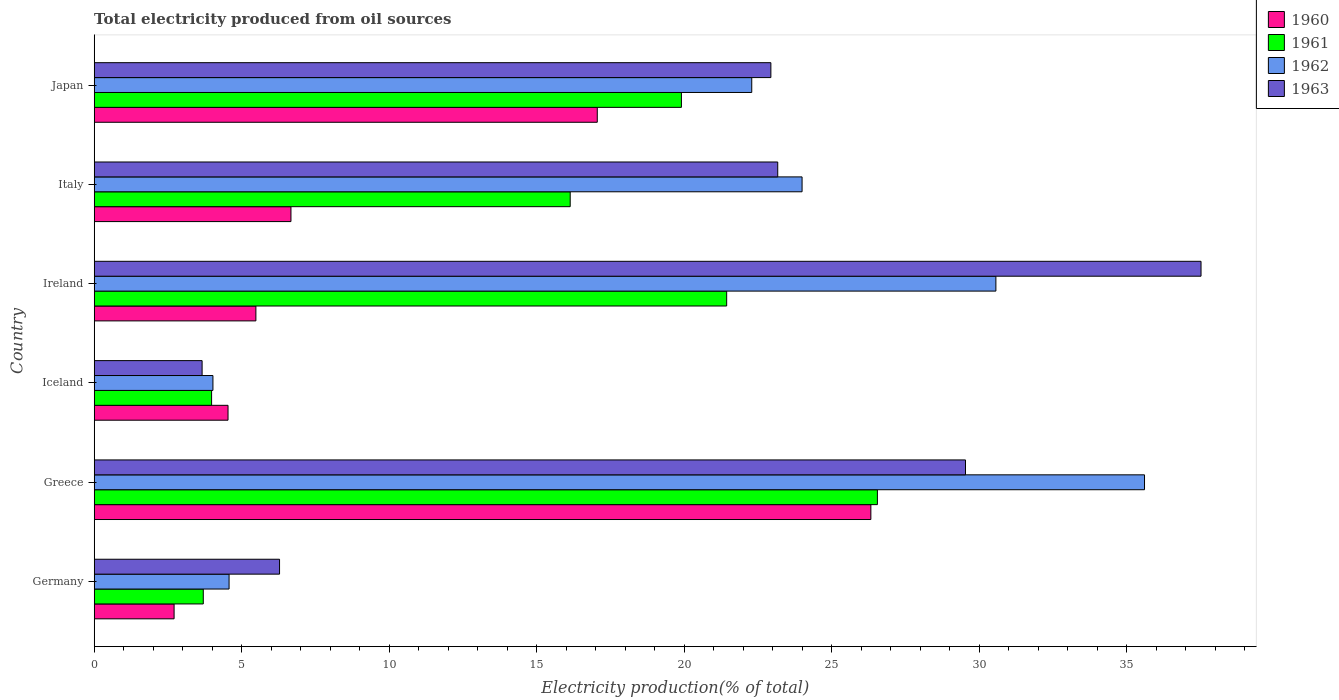How many different coloured bars are there?
Provide a succinct answer. 4. Are the number of bars on each tick of the Y-axis equal?
Your answer should be compact. Yes. What is the label of the 5th group of bars from the top?
Give a very brief answer. Greece. What is the total electricity produced in 1960 in Japan?
Keep it short and to the point. 17.06. Across all countries, what is the maximum total electricity produced in 1963?
Your response must be concise. 37.53. Across all countries, what is the minimum total electricity produced in 1961?
Your response must be concise. 3.7. What is the total total electricity produced in 1960 in the graph?
Provide a short and direct response. 62.79. What is the difference between the total electricity produced in 1962 in Germany and that in Greece?
Ensure brevity in your answer.  -31.04. What is the difference between the total electricity produced in 1962 in Japan and the total electricity produced in 1960 in Greece?
Offer a very short reply. -4.04. What is the average total electricity produced in 1962 per country?
Your answer should be very brief. 20.18. What is the difference between the total electricity produced in 1961 and total electricity produced in 1963 in Greece?
Provide a succinct answer. -2.99. What is the ratio of the total electricity produced in 1961 in Iceland to that in Ireland?
Ensure brevity in your answer.  0.19. Is the total electricity produced in 1962 in Iceland less than that in Ireland?
Offer a very short reply. Yes. What is the difference between the highest and the second highest total electricity produced in 1962?
Give a very brief answer. 5.04. What is the difference between the highest and the lowest total electricity produced in 1960?
Your answer should be compact. 23.62. In how many countries, is the total electricity produced in 1962 greater than the average total electricity produced in 1962 taken over all countries?
Give a very brief answer. 4. Is the sum of the total electricity produced in 1962 in Ireland and Italy greater than the maximum total electricity produced in 1961 across all countries?
Offer a very short reply. Yes. Is it the case that in every country, the sum of the total electricity produced in 1960 and total electricity produced in 1961 is greater than the sum of total electricity produced in 1963 and total electricity produced in 1962?
Your answer should be very brief. No. What does the 2nd bar from the top in Germany represents?
Keep it short and to the point. 1962. What does the 2nd bar from the bottom in Japan represents?
Offer a terse response. 1961. Is it the case that in every country, the sum of the total electricity produced in 1963 and total electricity produced in 1961 is greater than the total electricity produced in 1960?
Offer a terse response. Yes. How many bars are there?
Provide a short and direct response. 24. Are the values on the major ticks of X-axis written in scientific E-notation?
Give a very brief answer. No. Does the graph contain any zero values?
Your response must be concise. No. Does the graph contain grids?
Make the answer very short. No. Where does the legend appear in the graph?
Give a very brief answer. Top right. How are the legend labels stacked?
Provide a short and direct response. Vertical. What is the title of the graph?
Offer a very short reply. Total electricity produced from oil sources. What is the label or title of the X-axis?
Make the answer very short. Electricity production(% of total). What is the label or title of the Y-axis?
Your response must be concise. Country. What is the Electricity production(% of total) in 1960 in Germany?
Your response must be concise. 2.71. What is the Electricity production(% of total) in 1961 in Germany?
Your response must be concise. 3.7. What is the Electricity production(% of total) in 1962 in Germany?
Your answer should be very brief. 4.57. What is the Electricity production(% of total) of 1963 in Germany?
Your answer should be compact. 6.28. What is the Electricity production(% of total) in 1960 in Greece?
Your answer should be very brief. 26.33. What is the Electricity production(% of total) in 1961 in Greece?
Keep it short and to the point. 26.55. What is the Electricity production(% of total) in 1962 in Greece?
Your answer should be compact. 35.61. What is the Electricity production(% of total) of 1963 in Greece?
Ensure brevity in your answer.  29.54. What is the Electricity production(% of total) in 1960 in Iceland?
Ensure brevity in your answer.  4.54. What is the Electricity production(% of total) of 1961 in Iceland?
Ensure brevity in your answer.  3.98. What is the Electricity production(% of total) of 1962 in Iceland?
Your answer should be compact. 4.03. What is the Electricity production(% of total) in 1963 in Iceland?
Offer a very short reply. 3.66. What is the Electricity production(% of total) of 1960 in Ireland?
Give a very brief answer. 5.48. What is the Electricity production(% of total) in 1961 in Ireland?
Keep it short and to the point. 21.44. What is the Electricity production(% of total) of 1962 in Ireland?
Ensure brevity in your answer.  30.57. What is the Electricity production(% of total) in 1963 in Ireland?
Make the answer very short. 37.53. What is the Electricity production(% of total) of 1960 in Italy?
Your answer should be compact. 6.67. What is the Electricity production(% of total) of 1961 in Italy?
Make the answer very short. 16.14. What is the Electricity production(% of total) of 1962 in Italy?
Your answer should be very brief. 24. What is the Electricity production(% of total) of 1963 in Italy?
Your response must be concise. 23.17. What is the Electricity production(% of total) of 1960 in Japan?
Keep it short and to the point. 17.06. What is the Electricity production(% of total) in 1961 in Japan?
Give a very brief answer. 19.91. What is the Electricity production(% of total) of 1962 in Japan?
Your answer should be very brief. 22.29. What is the Electricity production(% of total) of 1963 in Japan?
Give a very brief answer. 22.94. Across all countries, what is the maximum Electricity production(% of total) of 1960?
Provide a succinct answer. 26.33. Across all countries, what is the maximum Electricity production(% of total) of 1961?
Your response must be concise. 26.55. Across all countries, what is the maximum Electricity production(% of total) in 1962?
Keep it short and to the point. 35.61. Across all countries, what is the maximum Electricity production(% of total) in 1963?
Provide a succinct answer. 37.53. Across all countries, what is the minimum Electricity production(% of total) in 1960?
Make the answer very short. 2.71. Across all countries, what is the minimum Electricity production(% of total) in 1961?
Provide a succinct answer. 3.7. Across all countries, what is the minimum Electricity production(% of total) in 1962?
Your answer should be compact. 4.03. Across all countries, what is the minimum Electricity production(% of total) in 1963?
Ensure brevity in your answer.  3.66. What is the total Electricity production(% of total) in 1960 in the graph?
Give a very brief answer. 62.79. What is the total Electricity production(% of total) in 1961 in the graph?
Your answer should be compact. 91.72. What is the total Electricity production(% of total) of 1962 in the graph?
Provide a short and direct response. 121.07. What is the total Electricity production(% of total) in 1963 in the graph?
Make the answer very short. 123.13. What is the difference between the Electricity production(% of total) of 1960 in Germany and that in Greece?
Offer a terse response. -23.62. What is the difference between the Electricity production(% of total) of 1961 in Germany and that in Greece?
Your answer should be very brief. -22.86. What is the difference between the Electricity production(% of total) in 1962 in Germany and that in Greece?
Provide a succinct answer. -31.04. What is the difference between the Electricity production(% of total) of 1963 in Germany and that in Greece?
Offer a terse response. -23.26. What is the difference between the Electricity production(% of total) of 1960 in Germany and that in Iceland?
Your answer should be very brief. -1.83. What is the difference between the Electricity production(% of total) in 1961 in Germany and that in Iceland?
Your answer should be very brief. -0.28. What is the difference between the Electricity production(% of total) in 1962 in Germany and that in Iceland?
Your answer should be very brief. 0.55. What is the difference between the Electricity production(% of total) of 1963 in Germany and that in Iceland?
Provide a short and direct response. 2.63. What is the difference between the Electricity production(% of total) in 1960 in Germany and that in Ireland?
Keep it short and to the point. -2.77. What is the difference between the Electricity production(% of total) of 1961 in Germany and that in Ireland?
Ensure brevity in your answer.  -17.75. What is the difference between the Electricity production(% of total) of 1962 in Germany and that in Ireland?
Offer a very short reply. -26. What is the difference between the Electricity production(% of total) of 1963 in Germany and that in Ireland?
Give a very brief answer. -31.24. What is the difference between the Electricity production(% of total) in 1960 in Germany and that in Italy?
Offer a terse response. -3.96. What is the difference between the Electricity production(% of total) of 1961 in Germany and that in Italy?
Offer a terse response. -12.44. What is the difference between the Electricity production(% of total) of 1962 in Germany and that in Italy?
Your response must be concise. -19.43. What is the difference between the Electricity production(% of total) in 1963 in Germany and that in Italy?
Ensure brevity in your answer.  -16.89. What is the difference between the Electricity production(% of total) of 1960 in Germany and that in Japan?
Offer a terse response. -14.35. What is the difference between the Electricity production(% of total) of 1961 in Germany and that in Japan?
Give a very brief answer. -16.21. What is the difference between the Electricity production(% of total) of 1962 in Germany and that in Japan?
Offer a terse response. -17.72. What is the difference between the Electricity production(% of total) in 1963 in Germany and that in Japan?
Offer a very short reply. -16.66. What is the difference between the Electricity production(% of total) of 1960 in Greece and that in Iceland?
Your response must be concise. 21.79. What is the difference between the Electricity production(% of total) in 1961 in Greece and that in Iceland?
Your answer should be compact. 22.57. What is the difference between the Electricity production(% of total) in 1962 in Greece and that in Iceland?
Offer a terse response. 31.58. What is the difference between the Electricity production(% of total) in 1963 in Greece and that in Iceland?
Keep it short and to the point. 25.88. What is the difference between the Electricity production(% of total) in 1960 in Greece and that in Ireland?
Provide a short and direct response. 20.85. What is the difference between the Electricity production(% of total) in 1961 in Greece and that in Ireland?
Offer a very short reply. 5.11. What is the difference between the Electricity production(% of total) in 1962 in Greece and that in Ireland?
Offer a very short reply. 5.04. What is the difference between the Electricity production(% of total) of 1963 in Greece and that in Ireland?
Keep it short and to the point. -7.99. What is the difference between the Electricity production(% of total) in 1960 in Greece and that in Italy?
Your answer should be very brief. 19.66. What is the difference between the Electricity production(% of total) of 1961 in Greece and that in Italy?
Provide a short and direct response. 10.42. What is the difference between the Electricity production(% of total) in 1962 in Greece and that in Italy?
Your answer should be compact. 11.61. What is the difference between the Electricity production(% of total) of 1963 in Greece and that in Italy?
Your response must be concise. 6.37. What is the difference between the Electricity production(% of total) in 1960 in Greece and that in Japan?
Make the answer very short. 9.28. What is the difference between the Electricity production(% of total) of 1961 in Greece and that in Japan?
Ensure brevity in your answer.  6.64. What is the difference between the Electricity production(% of total) of 1962 in Greece and that in Japan?
Keep it short and to the point. 13.32. What is the difference between the Electricity production(% of total) of 1963 in Greece and that in Japan?
Give a very brief answer. 6.6. What is the difference between the Electricity production(% of total) in 1960 in Iceland and that in Ireland?
Provide a succinct answer. -0.94. What is the difference between the Electricity production(% of total) of 1961 in Iceland and that in Ireland?
Keep it short and to the point. -17.46. What is the difference between the Electricity production(% of total) of 1962 in Iceland and that in Ireland?
Provide a succinct answer. -26.55. What is the difference between the Electricity production(% of total) in 1963 in Iceland and that in Ireland?
Offer a terse response. -33.87. What is the difference between the Electricity production(% of total) in 1960 in Iceland and that in Italy?
Provide a short and direct response. -2.13. What is the difference between the Electricity production(% of total) in 1961 in Iceland and that in Italy?
Provide a short and direct response. -12.16. What is the difference between the Electricity production(% of total) of 1962 in Iceland and that in Italy?
Your answer should be very brief. -19.97. What is the difference between the Electricity production(% of total) in 1963 in Iceland and that in Italy?
Provide a short and direct response. -19.52. What is the difference between the Electricity production(% of total) in 1960 in Iceland and that in Japan?
Your response must be concise. -12.52. What is the difference between the Electricity production(% of total) in 1961 in Iceland and that in Japan?
Your answer should be compact. -15.93. What is the difference between the Electricity production(% of total) in 1962 in Iceland and that in Japan?
Your answer should be very brief. -18.27. What is the difference between the Electricity production(% of total) of 1963 in Iceland and that in Japan?
Offer a very short reply. -19.28. What is the difference between the Electricity production(% of total) in 1960 in Ireland and that in Italy?
Keep it short and to the point. -1.19. What is the difference between the Electricity production(% of total) in 1961 in Ireland and that in Italy?
Offer a very short reply. 5.3. What is the difference between the Electricity production(% of total) in 1962 in Ireland and that in Italy?
Keep it short and to the point. 6.57. What is the difference between the Electricity production(% of total) of 1963 in Ireland and that in Italy?
Provide a succinct answer. 14.35. What is the difference between the Electricity production(% of total) in 1960 in Ireland and that in Japan?
Offer a terse response. -11.57. What is the difference between the Electricity production(% of total) of 1961 in Ireland and that in Japan?
Give a very brief answer. 1.53. What is the difference between the Electricity production(% of total) in 1962 in Ireland and that in Japan?
Give a very brief answer. 8.28. What is the difference between the Electricity production(% of total) in 1963 in Ireland and that in Japan?
Give a very brief answer. 14.58. What is the difference between the Electricity production(% of total) of 1960 in Italy and that in Japan?
Your answer should be compact. -10.39. What is the difference between the Electricity production(% of total) in 1961 in Italy and that in Japan?
Keep it short and to the point. -3.77. What is the difference between the Electricity production(% of total) of 1962 in Italy and that in Japan?
Keep it short and to the point. 1.71. What is the difference between the Electricity production(% of total) in 1963 in Italy and that in Japan?
Offer a terse response. 0.23. What is the difference between the Electricity production(% of total) in 1960 in Germany and the Electricity production(% of total) in 1961 in Greece?
Make the answer very short. -23.85. What is the difference between the Electricity production(% of total) in 1960 in Germany and the Electricity production(% of total) in 1962 in Greece?
Offer a terse response. -32.9. What is the difference between the Electricity production(% of total) of 1960 in Germany and the Electricity production(% of total) of 1963 in Greece?
Your answer should be compact. -26.83. What is the difference between the Electricity production(% of total) of 1961 in Germany and the Electricity production(% of total) of 1962 in Greece?
Your answer should be very brief. -31.91. What is the difference between the Electricity production(% of total) of 1961 in Germany and the Electricity production(% of total) of 1963 in Greece?
Your response must be concise. -25.84. What is the difference between the Electricity production(% of total) in 1962 in Germany and the Electricity production(% of total) in 1963 in Greece?
Make the answer very short. -24.97. What is the difference between the Electricity production(% of total) in 1960 in Germany and the Electricity production(% of total) in 1961 in Iceland?
Ensure brevity in your answer.  -1.27. What is the difference between the Electricity production(% of total) of 1960 in Germany and the Electricity production(% of total) of 1962 in Iceland?
Make the answer very short. -1.32. What is the difference between the Electricity production(% of total) of 1960 in Germany and the Electricity production(% of total) of 1963 in Iceland?
Give a very brief answer. -0.95. What is the difference between the Electricity production(% of total) in 1961 in Germany and the Electricity production(% of total) in 1962 in Iceland?
Ensure brevity in your answer.  -0.33. What is the difference between the Electricity production(% of total) of 1961 in Germany and the Electricity production(% of total) of 1963 in Iceland?
Provide a succinct answer. 0.04. What is the difference between the Electricity production(% of total) in 1962 in Germany and the Electricity production(% of total) in 1963 in Iceland?
Provide a succinct answer. 0.91. What is the difference between the Electricity production(% of total) in 1960 in Germany and the Electricity production(% of total) in 1961 in Ireland?
Your answer should be very brief. -18.73. What is the difference between the Electricity production(% of total) of 1960 in Germany and the Electricity production(% of total) of 1962 in Ireland?
Your answer should be compact. -27.86. What is the difference between the Electricity production(% of total) in 1960 in Germany and the Electricity production(% of total) in 1963 in Ireland?
Your response must be concise. -34.82. What is the difference between the Electricity production(% of total) in 1961 in Germany and the Electricity production(% of total) in 1962 in Ireland?
Give a very brief answer. -26.87. What is the difference between the Electricity production(% of total) of 1961 in Germany and the Electricity production(% of total) of 1963 in Ireland?
Provide a succinct answer. -33.83. What is the difference between the Electricity production(% of total) of 1962 in Germany and the Electricity production(% of total) of 1963 in Ireland?
Offer a very short reply. -32.95. What is the difference between the Electricity production(% of total) of 1960 in Germany and the Electricity production(% of total) of 1961 in Italy?
Your answer should be compact. -13.43. What is the difference between the Electricity production(% of total) in 1960 in Germany and the Electricity production(% of total) in 1962 in Italy?
Ensure brevity in your answer.  -21.29. What is the difference between the Electricity production(% of total) of 1960 in Germany and the Electricity production(% of total) of 1963 in Italy?
Give a very brief answer. -20.47. What is the difference between the Electricity production(% of total) of 1961 in Germany and the Electricity production(% of total) of 1962 in Italy?
Your response must be concise. -20.3. What is the difference between the Electricity production(% of total) of 1961 in Germany and the Electricity production(% of total) of 1963 in Italy?
Keep it short and to the point. -19.48. What is the difference between the Electricity production(% of total) in 1962 in Germany and the Electricity production(% of total) in 1963 in Italy?
Offer a terse response. -18.6. What is the difference between the Electricity production(% of total) in 1960 in Germany and the Electricity production(% of total) in 1961 in Japan?
Make the answer very short. -17.2. What is the difference between the Electricity production(% of total) of 1960 in Germany and the Electricity production(% of total) of 1962 in Japan?
Provide a short and direct response. -19.58. What is the difference between the Electricity production(% of total) in 1960 in Germany and the Electricity production(% of total) in 1963 in Japan?
Your response must be concise. -20.23. What is the difference between the Electricity production(% of total) of 1961 in Germany and the Electricity production(% of total) of 1962 in Japan?
Keep it short and to the point. -18.6. What is the difference between the Electricity production(% of total) in 1961 in Germany and the Electricity production(% of total) in 1963 in Japan?
Your response must be concise. -19.24. What is the difference between the Electricity production(% of total) in 1962 in Germany and the Electricity production(% of total) in 1963 in Japan?
Provide a short and direct response. -18.37. What is the difference between the Electricity production(% of total) of 1960 in Greece and the Electricity production(% of total) of 1961 in Iceland?
Ensure brevity in your answer.  22.35. What is the difference between the Electricity production(% of total) in 1960 in Greece and the Electricity production(% of total) in 1962 in Iceland?
Provide a short and direct response. 22.31. What is the difference between the Electricity production(% of total) in 1960 in Greece and the Electricity production(% of total) in 1963 in Iceland?
Provide a succinct answer. 22.67. What is the difference between the Electricity production(% of total) in 1961 in Greece and the Electricity production(% of total) in 1962 in Iceland?
Your response must be concise. 22.53. What is the difference between the Electricity production(% of total) in 1961 in Greece and the Electricity production(% of total) in 1963 in Iceland?
Give a very brief answer. 22.9. What is the difference between the Electricity production(% of total) in 1962 in Greece and the Electricity production(% of total) in 1963 in Iceland?
Provide a succinct answer. 31.95. What is the difference between the Electricity production(% of total) of 1960 in Greece and the Electricity production(% of total) of 1961 in Ireland?
Your answer should be compact. 4.89. What is the difference between the Electricity production(% of total) in 1960 in Greece and the Electricity production(% of total) in 1962 in Ireland?
Make the answer very short. -4.24. What is the difference between the Electricity production(% of total) of 1960 in Greece and the Electricity production(% of total) of 1963 in Ireland?
Your answer should be compact. -11.19. What is the difference between the Electricity production(% of total) in 1961 in Greece and the Electricity production(% of total) in 1962 in Ireland?
Provide a succinct answer. -4.02. What is the difference between the Electricity production(% of total) of 1961 in Greece and the Electricity production(% of total) of 1963 in Ireland?
Make the answer very short. -10.97. What is the difference between the Electricity production(% of total) in 1962 in Greece and the Electricity production(% of total) in 1963 in Ireland?
Ensure brevity in your answer.  -1.92. What is the difference between the Electricity production(% of total) in 1960 in Greece and the Electricity production(% of total) in 1961 in Italy?
Make the answer very short. 10.19. What is the difference between the Electricity production(% of total) in 1960 in Greece and the Electricity production(% of total) in 1962 in Italy?
Your answer should be compact. 2.33. What is the difference between the Electricity production(% of total) in 1960 in Greece and the Electricity production(% of total) in 1963 in Italy?
Provide a succinct answer. 3.16. What is the difference between the Electricity production(% of total) in 1961 in Greece and the Electricity production(% of total) in 1962 in Italy?
Give a very brief answer. 2.55. What is the difference between the Electricity production(% of total) of 1961 in Greece and the Electricity production(% of total) of 1963 in Italy?
Your answer should be very brief. 3.38. What is the difference between the Electricity production(% of total) of 1962 in Greece and the Electricity production(% of total) of 1963 in Italy?
Your response must be concise. 12.44. What is the difference between the Electricity production(% of total) in 1960 in Greece and the Electricity production(% of total) in 1961 in Japan?
Offer a terse response. 6.42. What is the difference between the Electricity production(% of total) of 1960 in Greece and the Electricity production(% of total) of 1962 in Japan?
Provide a succinct answer. 4.04. What is the difference between the Electricity production(% of total) in 1960 in Greece and the Electricity production(% of total) in 1963 in Japan?
Provide a short and direct response. 3.39. What is the difference between the Electricity production(% of total) of 1961 in Greece and the Electricity production(% of total) of 1962 in Japan?
Make the answer very short. 4.26. What is the difference between the Electricity production(% of total) in 1961 in Greece and the Electricity production(% of total) in 1963 in Japan?
Your response must be concise. 3.61. What is the difference between the Electricity production(% of total) in 1962 in Greece and the Electricity production(% of total) in 1963 in Japan?
Ensure brevity in your answer.  12.67. What is the difference between the Electricity production(% of total) of 1960 in Iceland and the Electricity production(% of total) of 1961 in Ireland?
Your answer should be very brief. -16.91. What is the difference between the Electricity production(% of total) in 1960 in Iceland and the Electricity production(% of total) in 1962 in Ireland?
Your answer should be compact. -26.03. What is the difference between the Electricity production(% of total) of 1960 in Iceland and the Electricity production(% of total) of 1963 in Ireland?
Give a very brief answer. -32.99. What is the difference between the Electricity production(% of total) in 1961 in Iceland and the Electricity production(% of total) in 1962 in Ireland?
Make the answer very short. -26.59. What is the difference between the Electricity production(% of total) of 1961 in Iceland and the Electricity production(% of total) of 1963 in Ireland?
Ensure brevity in your answer.  -33.55. What is the difference between the Electricity production(% of total) of 1962 in Iceland and the Electricity production(% of total) of 1963 in Ireland?
Your response must be concise. -33.5. What is the difference between the Electricity production(% of total) of 1960 in Iceland and the Electricity production(% of total) of 1961 in Italy?
Keep it short and to the point. -11.6. What is the difference between the Electricity production(% of total) in 1960 in Iceland and the Electricity production(% of total) in 1962 in Italy?
Your answer should be very brief. -19.46. What is the difference between the Electricity production(% of total) of 1960 in Iceland and the Electricity production(% of total) of 1963 in Italy?
Give a very brief answer. -18.64. What is the difference between the Electricity production(% of total) in 1961 in Iceland and the Electricity production(% of total) in 1962 in Italy?
Your answer should be very brief. -20.02. What is the difference between the Electricity production(% of total) of 1961 in Iceland and the Electricity production(% of total) of 1963 in Italy?
Offer a very short reply. -19.19. What is the difference between the Electricity production(% of total) in 1962 in Iceland and the Electricity production(% of total) in 1963 in Italy?
Give a very brief answer. -19.15. What is the difference between the Electricity production(% of total) of 1960 in Iceland and the Electricity production(% of total) of 1961 in Japan?
Give a very brief answer. -15.37. What is the difference between the Electricity production(% of total) in 1960 in Iceland and the Electricity production(% of total) in 1962 in Japan?
Provide a succinct answer. -17.76. What is the difference between the Electricity production(% of total) in 1960 in Iceland and the Electricity production(% of total) in 1963 in Japan?
Provide a succinct answer. -18.4. What is the difference between the Electricity production(% of total) of 1961 in Iceland and the Electricity production(% of total) of 1962 in Japan?
Make the answer very short. -18.31. What is the difference between the Electricity production(% of total) in 1961 in Iceland and the Electricity production(% of total) in 1963 in Japan?
Ensure brevity in your answer.  -18.96. What is the difference between the Electricity production(% of total) of 1962 in Iceland and the Electricity production(% of total) of 1963 in Japan?
Your answer should be compact. -18.92. What is the difference between the Electricity production(% of total) in 1960 in Ireland and the Electricity production(% of total) in 1961 in Italy?
Offer a very short reply. -10.66. What is the difference between the Electricity production(% of total) of 1960 in Ireland and the Electricity production(% of total) of 1962 in Italy?
Make the answer very short. -18.52. What is the difference between the Electricity production(% of total) in 1960 in Ireland and the Electricity production(% of total) in 1963 in Italy?
Make the answer very short. -17.69. What is the difference between the Electricity production(% of total) of 1961 in Ireland and the Electricity production(% of total) of 1962 in Italy?
Provide a short and direct response. -2.56. What is the difference between the Electricity production(% of total) in 1961 in Ireland and the Electricity production(% of total) in 1963 in Italy?
Your answer should be very brief. -1.73. What is the difference between the Electricity production(% of total) in 1962 in Ireland and the Electricity production(% of total) in 1963 in Italy?
Give a very brief answer. 7.4. What is the difference between the Electricity production(% of total) of 1960 in Ireland and the Electricity production(% of total) of 1961 in Japan?
Keep it short and to the point. -14.43. What is the difference between the Electricity production(% of total) in 1960 in Ireland and the Electricity production(% of total) in 1962 in Japan?
Your response must be concise. -16.81. What is the difference between the Electricity production(% of total) of 1960 in Ireland and the Electricity production(% of total) of 1963 in Japan?
Your answer should be very brief. -17.46. What is the difference between the Electricity production(% of total) in 1961 in Ireland and the Electricity production(% of total) in 1962 in Japan?
Your answer should be compact. -0.85. What is the difference between the Electricity production(% of total) in 1961 in Ireland and the Electricity production(% of total) in 1963 in Japan?
Your answer should be very brief. -1.5. What is the difference between the Electricity production(% of total) of 1962 in Ireland and the Electricity production(% of total) of 1963 in Japan?
Provide a succinct answer. 7.63. What is the difference between the Electricity production(% of total) of 1960 in Italy and the Electricity production(% of total) of 1961 in Japan?
Provide a succinct answer. -13.24. What is the difference between the Electricity production(% of total) of 1960 in Italy and the Electricity production(% of total) of 1962 in Japan?
Ensure brevity in your answer.  -15.62. What is the difference between the Electricity production(% of total) in 1960 in Italy and the Electricity production(% of total) in 1963 in Japan?
Your response must be concise. -16.27. What is the difference between the Electricity production(% of total) of 1961 in Italy and the Electricity production(% of total) of 1962 in Japan?
Offer a very short reply. -6.15. What is the difference between the Electricity production(% of total) in 1961 in Italy and the Electricity production(% of total) in 1963 in Japan?
Your answer should be compact. -6.8. What is the difference between the Electricity production(% of total) of 1962 in Italy and the Electricity production(% of total) of 1963 in Japan?
Your answer should be very brief. 1.06. What is the average Electricity production(% of total) of 1960 per country?
Give a very brief answer. 10.46. What is the average Electricity production(% of total) in 1961 per country?
Your answer should be compact. 15.29. What is the average Electricity production(% of total) of 1962 per country?
Ensure brevity in your answer.  20.18. What is the average Electricity production(% of total) in 1963 per country?
Your answer should be very brief. 20.52. What is the difference between the Electricity production(% of total) of 1960 and Electricity production(% of total) of 1961 in Germany?
Give a very brief answer. -0.99. What is the difference between the Electricity production(% of total) in 1960 and Electricity production(% of total) in 1962 in Germany?
Provide a short and direct response. -1.86. What is the difference between the Electricity production(% of total) of 1960 and Electricity production(% of total) of 1963 in Germany?
Ensure brevity in your answer.  -3.58. What is the difference between the Electricity production(% of total) in 1961 and Electricity production(% of total) in 1962 in Germany?
Your answer should be compact. -0.87. What is the difference between the Electricity production(% of total) of 1961 and Electricity production(% of total) of 1963 in Germany?
Your response must be concise. -2.59. What is the difference between the Electricity production(% of total) of 1962 and Electricity production(% of total) of 1963 in Germany?
Make the answer very short. -1.71. What is the difference between the Electricity production(% of total) of 1960 and Electricity production(% of total) of 1961 in Greece?
Keep it short and to the point. -0.22. What is the difference between the Electricity production(% of total) in 1960 and Electricity production(% of total) in 1962 in Greece?
Give a very brief answer. -9.28. What is the difference between the Electricity production(% of total) in 1960 and Electricity production(% of total) in 1963 in Greece?
Offer a very short reply. -3.21. What is the difference between the Electricity production(% of total) in 1961 and Electricity production(% of total) in 1962 in Greece?
Your answer should be compact. -9.06. What is the difference between the Electricity production(% of total) in 1961 and Electricity production(% of total) in 1963 in Greece?
Your answer should be very brief. -2.99. What is the difference between the Electricity production(% of total) in 1962 and Electricity production(% of total) in 1963 in Greece?
Make the answer very short. 6.07. What is the difference between the Electricity production(% of total) of 1960 and Electricity production(% of total) of 1961 in Iceland?
Provide a succinct answer. 0.56. What is the difference between the Electricity production(% of total) in 1960 and Electricity production(% of total) in 1962 in Iceland?
Give a very brief answer. 0.51. What is the difference between the Electricity production(% of total) in 1960 and Electricity production(% of total) in 1963 in Iceland?
Offer a terse response. 0.88. What is the difference between the Electricity production(% of total) of 1961 and Electricity production(% of total) of 1962 in Iceland?
Offer a very short reply. -0.05. What is the difference between the Electricity production(% of total) in 1961 and Electricity production(% of total) in 1963 in Iceland?
Your response must be concise. 0.32. What is the difference between the Electricity production(% of total) in 1962 and Electricity production(% of total) in 1963 in Iceland?
Make the answer very short. 0.37. What is the difference between the Electricity production(% of total) in 1960 and Electricity production(% of total) in 1961 in Ireland?
Keep it short and to the point. -15.96. What is the difference between the Electricity production(% of total) in 1960 and Electricity production(% of total) in 1962 in Ireland?
Your answer should be very brief. -25.09. What is the difference between the Electricity production(% of total) of 1960 and Electricity production(% of total) of 1963 in Ireland?
Your response must be concise. -32.04. What is the difference between the Electricity production(% of total) in 1961 and Electricity production(% of total) in 1962 in Ireland?
Offer a terse response. -9.13. What is the difference between the Electricity production(% of total) in 1961 and Electricity production(% of total) in 1963 in Ireland?
Your answer should be very brief. -16.08. What is the difference between the Electricity production(% of total) in 1962 and Electricity production(% of total) in 1963 in Ireland?
Provide a succinct answer. -6.95. What is the difference between the Electricity production(% of total) in 1960 and Electricity production(% of total) in 1961 in Italy?
Give a very brief answer. -9.47. What is the difference between the Electricity production(% of total) in 1960 and Electricity production(% of total) in 1962 in Italy?
Offer a very short reply. -17.33. What is the difference between the Electricity production(% of total) in 1960 and Electricity production(% of total) in 1963 in Italy?
Make the answer very short. -16.5. What is the difference between the Electricity production(% of total) in 1961 and Electricity production(% of total) in 1962 in Italy?
Your answer should be very brief. -7.86. What is the difference between the Electricity production(% of total) of 1961 and Electricity production(% of total) of 1963 in Italy?
Your answer should be very brief. -7.04. What is the difference between the Electricity production(% of total) in 1962 and Electricity production(% of total) in 1963 in Italy?
Give a very brief answer. 0.83. What is the difference between the Electricity production(% of total) of 1960 and Electricity production(% of total) of 1961 in Japan?
Your answer should be compact. -2.85. What is the difference between the Electricity production(% of total) in 1960 and Electricity production(% of total) in 1962 in Japan?
Provide a short and direct response. -5.24. What is the difference between the Electricity production(% of total) of 1960 and Electricity production(% of total) of 1963 in Japan?
Provide a short and direct response. -5.89. What is the difference between the Electricity production(% of total) of 1961 and Electricity production(% of total) of 1962 in Japan?
Offer a very short reply. -2.38. What is the difference between the Electricity production(% of total) in 1961 and Electricity production(% of total) in 1963 in Japan?
Make the answer very short. -3.03. What is the difference between the Electricity production(% of total) in 1962 and Electricity production(% of total) in 1963 in Japan?
Keep it short and to the point. -0.65. What is the ratio of the Electricity production(% of total) of 1960 in Germany to that in Greece?
Provide a succinct answer. 0.1. What is the ratio of the Electricity production(% of total) in 1961 in Germany to that in Greece?
Provide a short and direct response. 0.14. What is the ratio of the Electricity production(% of total) in 1962 in Germany to that in Greece?
Offer a very short reply. 0.13. What is the ratio of the Electricity production(% of total) in 1963 in Germany to that in Greece?
Ensure brevity in your answer.  0.21. What is the ratio of the Electricity production(% of total) of 1960 in Germany to that in Iceland?
Offer a very short reply. 0.6. What is the ratio of the Electricity production(% of total) in 1961 in Germany to that in Iceland?
Ensure brevity in your answer.  0.93. What is the ratio of the Electricity production(% of total) in 1962 in Germany to that in Iceland?
Keep it short and to the point. 1.14. What is the ratio of the Electricity production(% of total) in 1963 in Germany to that in Iceland?
Provide a short and direct response. 1.72. What is the ratio of the Electricity production(% of total) of 1960 in Germany to that in Ireland?
Keep it short and to the point. 0.49. What is the ratio of the Electricity production(% of total) of 1961 in Germany to that in Ireland?
Ensure brevity in your answer.  0.17. What is the ratio of the Electricity production(% of total) of 1962 in Germany to that in Ireland?
Offer a terse response. 0.15. What is the ratio of the Electricity production(% of total) of 1963 in Germany to that in Ireland?
Ensure brevity in your answer.  0.17. What is the ratio of the Electricity production(% of total) of 1960 in Germany to that in Italy?
Offer a very short reply. 0.41. What is the ratio of the Electricity production(% of total) of 1961 in Germany to that in Italy?
Ensure brevity in your answer.  0.23. What is the ratio of the Electricity production(% of total) in 1962 in Germany to that in Italy?
Keep it short and to the point. 0.19. What is the ratio of the Electricity production(% of total) in 1963 in Germany to that in Italy?
Make the answer very short. 0.27. What is the ratio of the Electricity production(% of total) in 1960 in Germany to that in Japan?
Give a very brief answer. 0.16. What is the ratio of the Electricity production(% of total) of 1961 in Germany to that in Japan?
Your response must be concise. 0.19. What is the ratio of the Electricity production(% of total) in 1962 in Germany to that in Japan?
Keep it short and to the point. 0.21. What is the ratio of the Electricity production(% of total) in 1963 in Germany to that in Japan?
Make the answer very short. 0.27. What is the ratio of the Electricity production(% of total) in 1960 in Greece to that in Iceland?
Provide a short and direct response. 5.8. What is the ratio of the Electricity production(% of total) in 1961 in Greece to that in Iceland?
Provide a short and direct response. 6.67. What is the ratio of the Electricity production(% of total) of 1962 in Greece to that in Iceland?
Keep it short and to the point. 8.85. What is the ratio of the Electricity production(% of total) of 1963 in Greece to that in Iceland?
Your response must be concise. 8.07. What is the ratio of the Electricity production(% of total) in 1960 in Greece to that in Ireland?
Offer a terse response. 4.8. What is the ratio of the Electricity production(% of total) in 1961 in Greece to that in Ireland?
Offer a terse response. 1.24. What is the ratio of the Electricity production(% of total) of 1962 in Greece to that in Ireland?
Make the answer very short. 1.16. What is the ratio of the Electricity production(% of total) of 1963 in Greece to that in Ireland?
Your response must be concise. 0.79. What is the ratio of the Electricity production(% of total) in 1960 in Greece to that in Italy?
Ensure brevity in your answer.  3.95. What is the ratio of the Electricity production(% of total) of 1961 in Greece to that in Italy?
Make the answer very short. 1.65. What is the ratio of the Electricity production(% of total) in 1962 in Greece to that in Italy?
Offer a terse response. 1.48. What is the ratio of the Electricity production(% of total) of 1963 in Greece to that in Italy?
Make the answer very short. 1.27. What is the ratio of the Electricity production(% of total) of 1960 in Greece to that in Japan?
Offer a very short reply. 1.54. What is the ratio of the Electricity production(% of total) in 1961 in Greece to that in Japan?
Offer a terse response. 1.33. What is the ratio of the Electricity production(% of total) of 1962 in Greece to that in Japan?
Make the answer very short. 1.6. What is the ratio of the Electricity production(% of total) in 1963 in Greece to that in Japan?
Your response must be concise. 1.29. What is the ratio of the Electricity production(% of total) in 1960 in Iceland to that in Ireland?
Make the answer very short. 0.83. What is the ratio of the Electricity production(% of total) of 1961 in Iceland to that in Ireland?
Your response must be concise. 0.19. What is the ratio of the Electricity production(% of total) of 1962 in Iceland to that in Ireland?
Provide a short and direct response. 0.13. What is the ratio of the Electricity production(% of total) in 1963 in Iceland to that in Ireland?
Your answer should be very brief. 0.1. What is the ratio of the Electricity production(% of total) of 1960 in Iceland to that in Italy?
Offer a terse response. 0.68. What is the ratio of the Electricity production(% of total) of 1961 in Iceland to that in Italy?
Offer a terse response. 0.25. What is the ratio of the Electricity production(% of total) in 1962 in Iceland to that in Italy?
Give a very brief answer. 0.17. What is the ratio of the Electricity production(% of total) in 1963 in Iceland to that in Italy?
Make the answer very short. 0.16. What is the ratio of the Electricity production(% of total) in 1960 in Iceland to that in Japan?
Offer a very short reply. 0.27. What is the ratio of the Electricity production(% of total) in 1961 in Iceland to that in Japan?
Your response must be concise. 0.2. What is the ratio of the Electricity production(% of total) of 1962 in Iceland to that in Japan?
Provide a short and direct response. 0.18. What is the ratio of the Electricity production(% of total) in 1963 in Iceland to that in Japan?
Provide a short and direct response. 0.16. What is the ratio of the Electricity production(% of total) of 1960 in Ireland to that in Italy?
Your answer should be very brief. 0.82. What is the ratio of the Electricity production(% of total) in 1961 in Ireland to that in Italy?
Your answer should be compact. 1.33. What is the ratio of the Electricity production(% of total) in 1962 in Ireland to that in Italy?
Offer a very short reply. 1.27. What is the ratio of the Electricity production(% of total) of 1963 in Ireland to that in Italy?
Your answer should be compact. 1.62. What is the ratio of the Electricity production(% of total) of 1960 in Ireland to that in Japan?
Offer a very short reply. 0.32. What is the ratio of the Electricity production(% of total) of 1961 in Ireland to that in Japan?
Make the answer very short. 1.08. What is the ratio of the Electricity production(% of total) in 1962 in Ireland to that in Japan?
Ensure brevity in your answer.  1.37. What is the ratio of the Electricity production(% of total) of 1963 in Ireland to that in Japan?
Offer a terse response. 1.64. What is the ratio of the Electricity production(% of total) of 1960 in Italy to that in Japan?
Make the answer very short. 0.39. What is the ratio of the Electricity production(% of total) of 1961 in Italy to that in Japan?
Provide a succinct answer. 0.81. What is the ratio of the Electricity production(% of total) of 1962 in Italy to that in Japan?
Your answer should be compact. 1.08. What is the difference between the highest and the second highest Electricity production(% of total) of 1960?
Ensure brevity in your answer.  9.28. What is the difference between the highest and the second highest Electricity production(% of total) in 1961?
Offer a terse response. 5.11. What is the difference between the highest and the second highest Electricity production(% of total) of 1962?
Your response must be concise. 5.04. What is the difference between the highest and the second highest Electricity production(% of total) of 1963?
Keep it short and to the point. 7.99. What is the difference between the highest and the lowest Electricity production(% of total) in 1960?
Ensure brevity in your answer.  23.62. What is the difference between the highest and the lowest Electricity production(% of total) of 1961?
Your answer should be very brief. 22.86. What is the difference between the highest and the lowest Electricity production(% of total) in 1962?
Offer a very short reply. 31.58. What is the difference between the highest and the lowest Electricity production(% of total) of 1963?
Give a very brief answer. 33.87. 